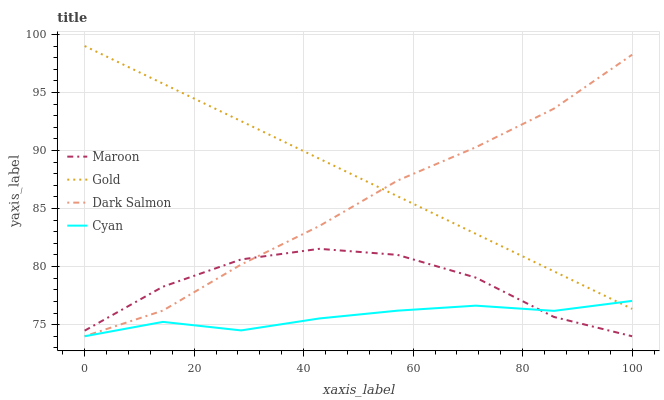Does Cyan have the minimum area under the curve?
Answer yes or no. Yes. Does Gold have the maximum area under the curve?
Answer yes or no. Yes. Does Maroon have the minimum area under the curve?
Answer yes or no. No. Does Maroon have the maximum area under the curve?
Answer yes or no. No. Is Gold the smoothest?
Answer yes or no. Yes. Is Maroon the roughest?
Answer yes or no. Yes. Is Maroon the smoothest?
Answer yes or no. No. Is Gold the roughest?
Answer yes or no. No. Does Gold have the lowest value?
Answer yes or no. No. Does Maroon have the highest value?
Answer yes or no. No. Is Maroon less than Gold?
Answer yes or no. Yes. Is Gold greater than Maroon?
Answer yes or no. Yes. Does Maroon intersect Gold?
Answer yes or no. No. 